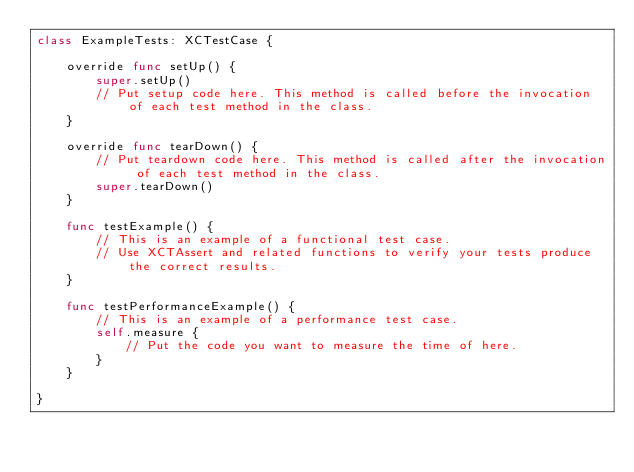<code> <loc_0><loc_0><loc_500><loc_500><_Swift_>class ExampleTests: XCTestCase {
    
    override func setUp() {
        super.setUp()
        // Put setup code here. This method is called before the invocation of each test method in the class.
    }
    
    override func tearDown() {
        // Put teardown code here. This method is called after the invocation of each test method in the class.
        super.tearDown()
    }
    
    func testExample() {
        // This is an example of a functional test case.
        // Use XCTAssert and related functions to verify your tests produce the correct results.
    }
    
    func testPerformanceExample() {
        // This is an example of a performance test case.
        self.measure {
            // Put the code you want to measure the time of here.
        }
    }
    
}
</code> 